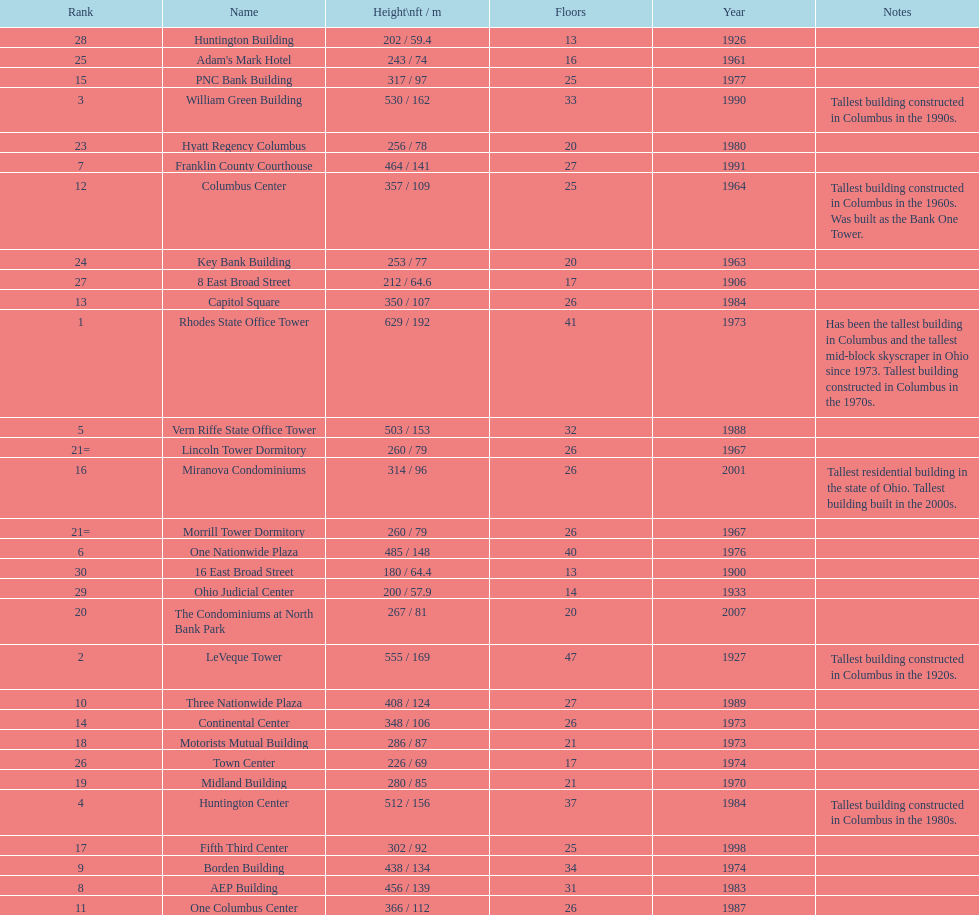What is the number of buildings under 200 ft? 1. 